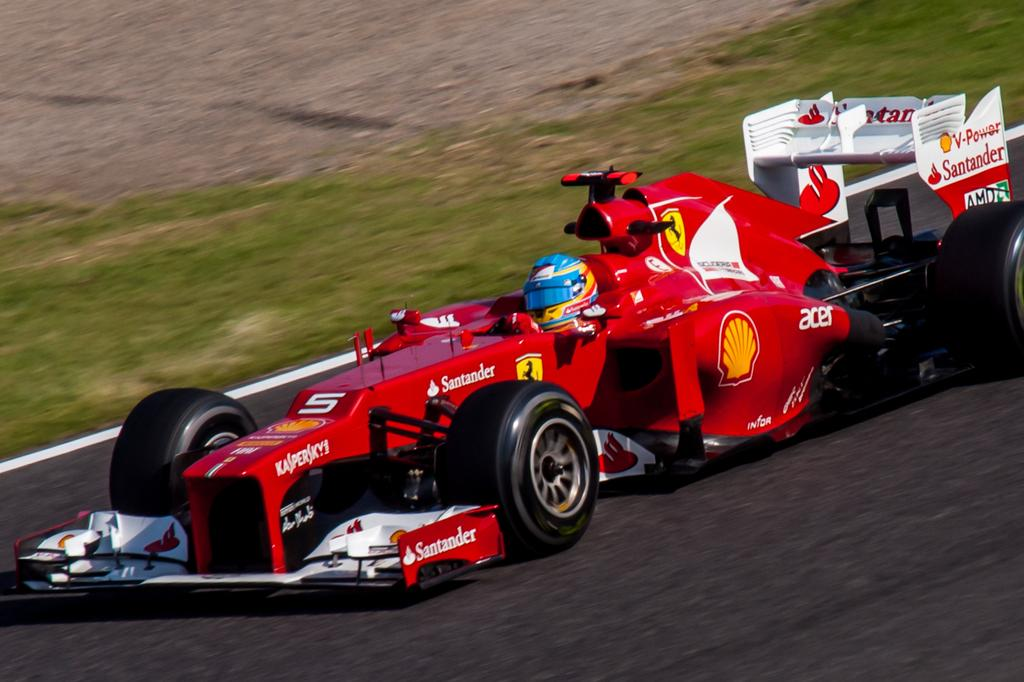What is the main subject of the image? There is a person in a car in the image. Where is the car located? The car is on the road. What can be seen in the background of the image? There is grass visible in the background of the image. How many cherries are on the card in the image? There are no cherries or cards present in the image; it features a person in a car on the road with grass in the background. 